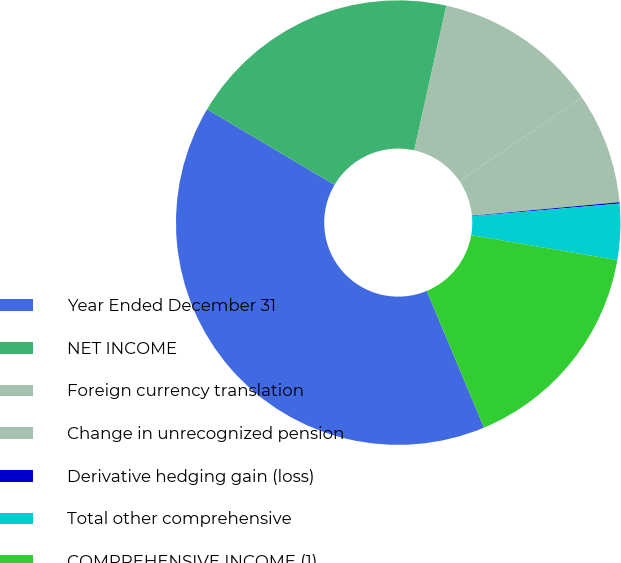Convert chart. <chart><loc_0><loc_0><loc_500><loc_500><pie_chart><fcel>Year Ended December 31<fcel>NET INCOME<fcel>Foreign currency translation<fcel>Change in unrecognized pension<fcel>Derivative hedging gain (loss)<fcel>Total other comprehensive<fcel>COMPREHENSIVE INCOME (1)<nl><fcel>39.83%<fcel>19.96%<fcel>12.02%<fcel>8.04%<fcel>0.1%<fcel>4.07%<fcel>15.99%<nl></chart> 